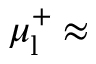<formula> <loc_0><loc_0><loc_500><loc_500>\mu _ { l } ^ { + } \approx</formula> 